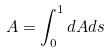Convert formula to latex. <formula><loc_0><loc_0><loc_500><loc_500>A = \int _ { 0 } ^ { 1 } d A d s</formula> 